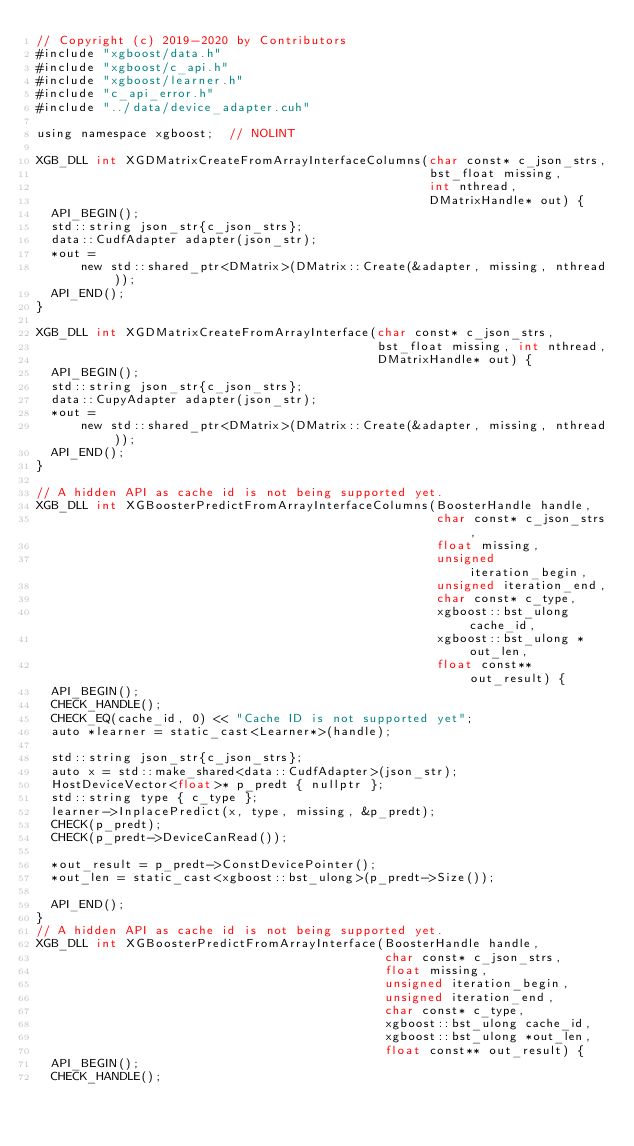<code> <loc_0><loc_0><loc_500><loc_500><_Cuda_>// Copyright (c) 2019-2020 by Contributors
#include "xgboost/data.h"
#include "xgboost/c_api.h"
#include "xgboost/learner.h"
#include "c_api_error.h"
#include "../data/device_adapter.cuh"

using namespace xgboost;  // NOLINT

XGB_DLL int XGDMatrixCreateFromArrayInterfaceColumns(char const* c_json_strs,
                                                     bst_float missing,
                                                     int nthread,
                                                     DMatrixHandle* out) {
  API_BEGIN();
  std::string json_str{c_json_strs};
  data::CudfAdapter adapter(json_str);
  *out =
      new std::shared_ptr<DMatrix>(DMatrix::Create(&adapter, missing, nthread));
  API_END();
}

XGB_DLL int XGDMatrixCreateFromArrayInterface(char const* c_json_strs,
                                              bst_float missing, int nthread,
                                              DMatrixHandle* out) {
  API_BEGIN();
  std::string json_str{c_json_strs};
  data::CupyAdapter adapter(json_str);
  *out =
      new std::shared_ptr<DMatrix>(DMatrix::Create(&adapter, missing, nthread));
  API_END();
}

// A hidden API as cache id is not being supported yet.
XGB_DLL int XGBoosterPredictFromArrayInterfaceColumns(BoosterHandle handle,
                                                      char const* c_json_strs,
                                                      float missing,
                                                      unsigned iteration_begin,
                                                      unsigned iteration_end,
                                                      char const* c_type,
                                                      xgboost::bst_ulong cache_id,
                                                      xgboost::bst_ulong *out_len,
                                                      float const** out_result) {
  API_BEGIN();
  CHECK_HANDLE();
  CHECK_EQ(cache_id, 0) << "Cache ID is not supported yet";
  auto *learner = static_cast<Learner*>(handle);

  std::string json_str{c_json_strs};
  auto x = std::make_shared<data::CudfAdapter>(json_str);
  HostDeviceVector<float>* p_predt { nullptr };
  std::string type { c_type };
  learner->InplacePredict(x, type, missing, &p_predt);
  CHECK(p_predt);
  CHECK(p_predt->DeviceCanRead());

  *out_result = p_predt->ConstDevicePointer();
  *out_len = static_cast<xgboost::bst_ulong>(p_predt->Size());

  API_END();
}
// A hidden API as cache id is not being supported yet.
XGB_DLL int XGBoosterPredictFromArrayInterface(BoosterHandle handle,
                                               char const* c_json_strs,
                                               float missing,
                                               unsigned iteration_begin,
                                               unsigned iteration_end,
                                               char const* c_type,
                                               xgboost::bst_ulong cache_id,
                                               xgboost::bst_ulong *out_len,
                                               float const** out_result) {
  API_BEGIN();
  CHECK_HANDLE();</code> 